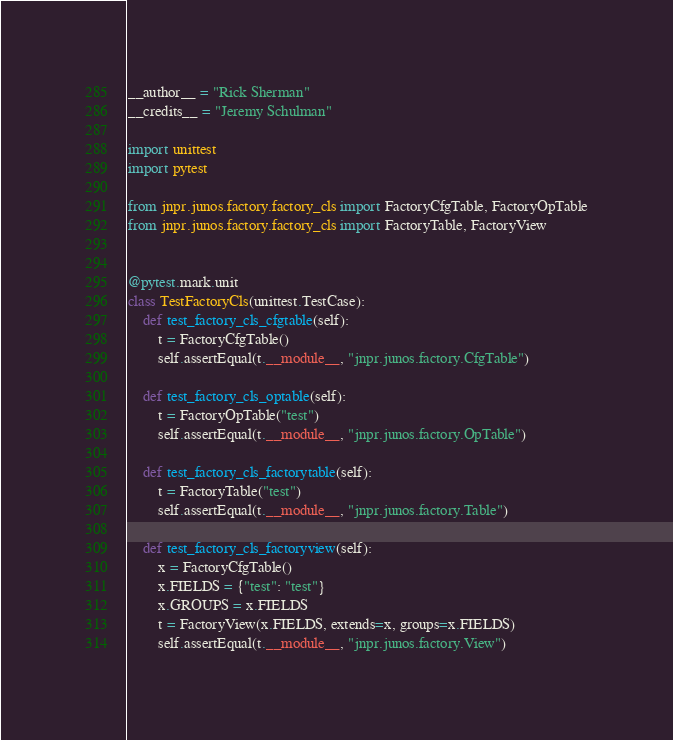Convert code to text. <code><loc_0><loc_0><loc_500><loc_500><_Python_>__author__ = "Rick Sherman"
__credits__ = "Jeremy Schulman"

import unittest
import pytest

from jnpr.junos.factory.factory_cls import FactoryCfgTable, FactoryOpTable
from jnpr.junos.factory.factory_cls import FactoryTable, FactoryView


@pytest.mark.unit
class TestFactoryCls(unittest.TestCase):
    def test_factory_cls_cfgtable(self):
        t = FactoryCfgTable()
        self.assertEqual(t.__module__, "jnpr.junos.factory.CfgTable")

    def test_factory_cls_optable(self):
        t = FactoryOpTable("test")
        self.assertEqual(t.__module__, "jnpr.junos.factory.OpTable")

    def test_factory_cls_factorytable(self):
        t = FactoryTable("test")
        self.assertEqual(t.__module__, "jnpr.junos.factory.Table")

    def test_factory_cls_factoryview(self):
        x = FactoryCfgTable()
        x.FIELDS = {"test": "test"}
        x.GROUPS = x.FIELDS
        t = FactoryView(x.FIELDS, extends=x, groups=x.FIELDS)
        self.assertEqual(t.__module__, "jnpr.junos.factory.View")
</code> 